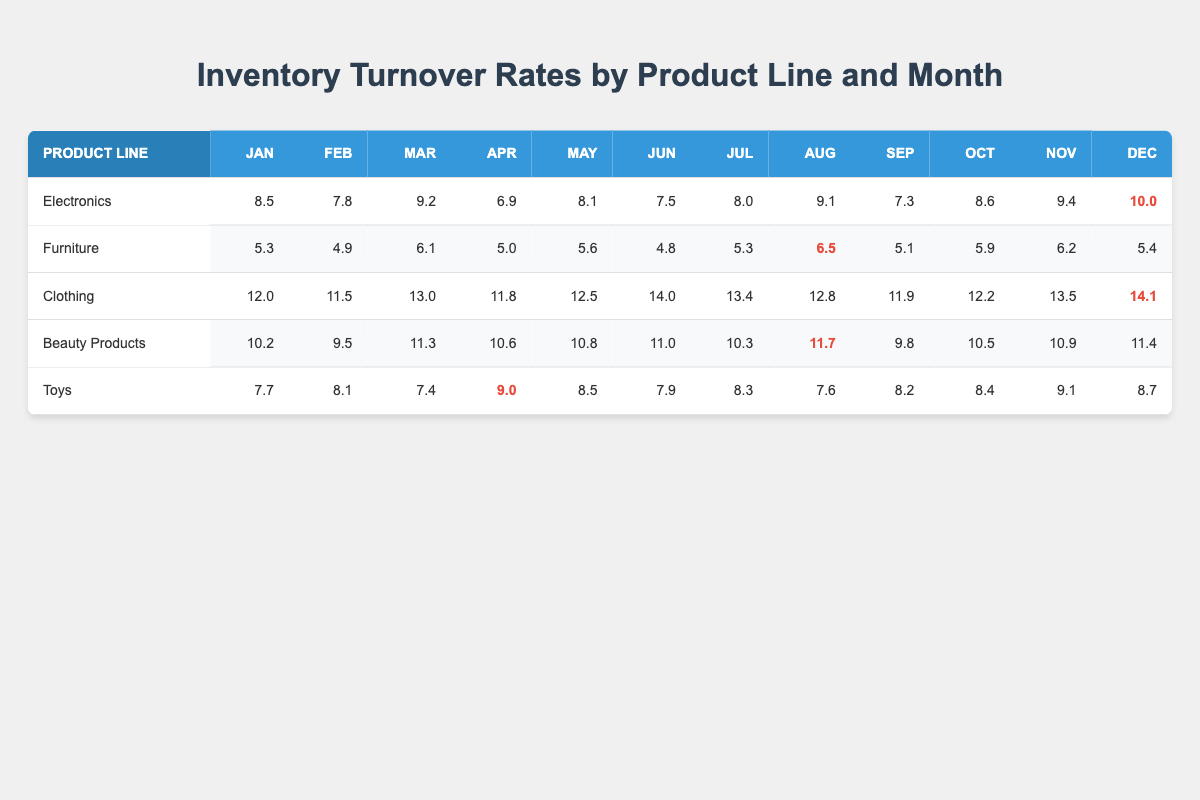What is the highest inventory turnover rate for Electronics, and in which month does it occur? Looking at the Electronics row, the maximum value is 10.0, which is found in December.
Answer: 10.0 in December What was the average inventory turnover rate for Furniture from January to December? To find the average, sum the values for Furniture: (5.3 + 4.9 + 6.1 + 5.0 + 5.6 + 4.8 + 5.3 + 6.5 + 5.1 + 5.9 + 6.2 + 5.4) which equals 64.7. Then, divide by 12 months: 64.7 / 12 = 5.39.
Answer: 5.39 Did Clothing have a turnover rate of at least 12.0 in every month? Checking the Clothing row reveals that in January, February, April, and September, the turnover rates are below 12.0, confirming the statement is false.
Answer: No Which product line had the smallest turnover rate in June? By inspecting the June column, the Furniture line has the lowest turnover rate with a value of 4.8.
Answer: Furniture with 4.8 What is the difference in turnover rates between the highest and lowest values of Beauty Products? The highest value for Beauty Products is 11.7 (August), and the lowest is 9.5 (February). The difference is 11.7 - 9.5 = 2.2.
Answer: 2.2 How many times did the clothing turnover rate exceed 12.0? Looking at the Clothing row, the values above 12.0 are: 12.0 (January), 12.5 (May), 14.0 (June), 13.4 (July), 12.8 (August), 13.5 (November), and 14.1 (December), totaling 7 occurrences.
Answer: 7 times Which product line had the highest turnover rate in any month? Reviewing all the rows reveals that Clothing has the highest value of 14.1 in December, which is the greatest among all product lines.
Answer: Clothing with 14.1 in December What was the trend for turnover rates in Toys from January to December? Evaluating the monthly values for Toys reveals fluctuations: starting from 7.7 in January, rising and falling continuously but overall shows variations with no clear increasing or decreasing trend.
Answer: Fluctuating with no clear trend 